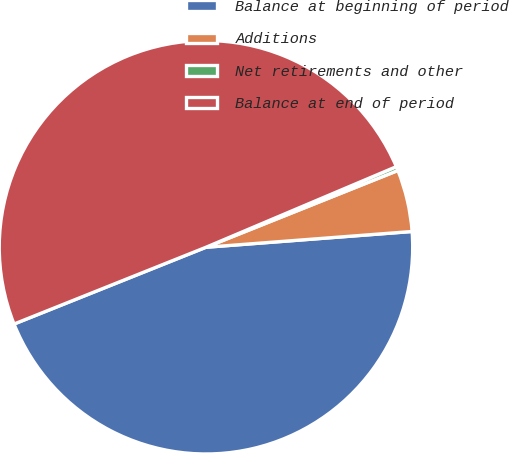Convert chart. <chart><loc_0><loc_0><loc_500><loc_500><pie_chart><fcel>Balance at beginning of period<fcel>Additions<fcel>Net retirements and other<fcel>Balance at end of period<nl><fcel>45.16%<fcel>4.84%<fcel>0.32%<fcel>49.68%<nl></chart> 